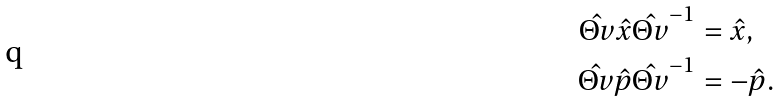<formula> <loc_0><loc_0><loc_500><loc_500>\hat { \Theta v } \hat { x } \hat { \Theta v } ^ { - 1 } & = \hat { x } , \\ \hat { \Theta v } \hat { p } \hat { \Theta v } ^ { - 1 } & = - \hat { p } .</formula> 